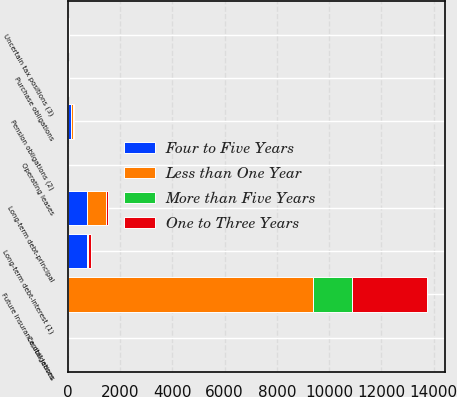<chart> <loc_0><loc_0><loc_500><loc_500><stacked_bar_chart><ecel><fcel>Long-term debt-principal<fcel>Long-term debt-interest (1)<fcel>Capital leases<fcel>Operating leases<fcel>Purchase obligations<fcel>Pension obligations (2)<fcel>Uncertain tax positions (3)<fcel>Future insurance obligations<nl><fcel>Less than One Year<fcel>721<fcel>9<fcel>0<fcel>0<fcel>10<fcel>54<fcel>15<fcel>9382<nl><fcel>Four to Five Years<fcel>733<fcel>726<fcel>0<fcel>12<fcel>10<fcel>138<fcel>15<fcel>12<nl><fcel>More than Five Years<fcel>0<fcel>53<fcel>0<fcel>3<fcel>10<fcel>12<fcel>6<fcel>1493<nl><fcel>One to Three Years<fcel>99<fcel>95<fcel>0<fcel>4<fcel>0<fcel>21<fcel>9<fcel>2857<nl></chart> 